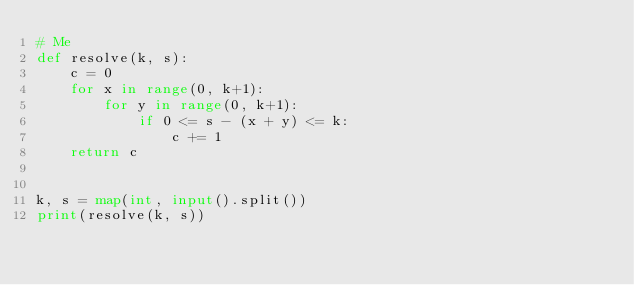<code> <loc_0><loc_0><loc_500><loc_500><_Python_># Me
def resolve(k, s):
    c = 0
    for x in range(0, k+1):
        for y in range(0, k+1):
            if 0 <= s - (x + y) <= k:
                c += 1
    return c


k, s = map(int, input().split())
print(resolve(k, s))
</code> 